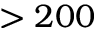Convert formula to latex. <formula><loc_0><loc_0><loc_500><loc_500>> 2 0 0</formula> 